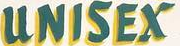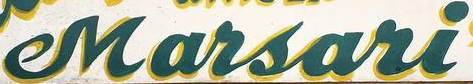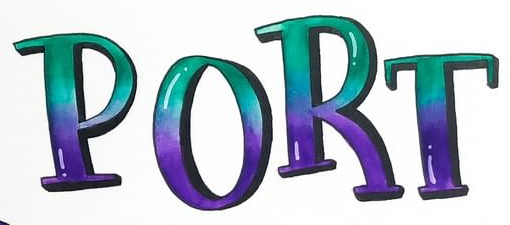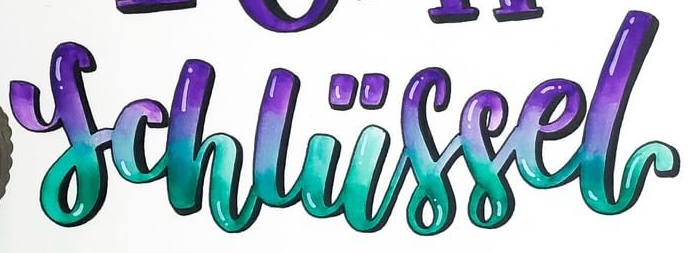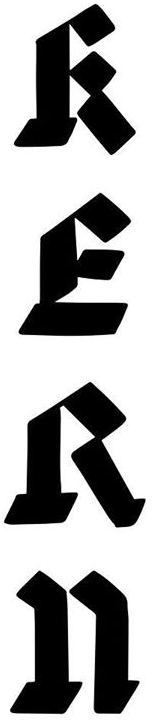Read the text content from these images in order, separated by a semicolon. UNISEX; Marsari; PORT; schliissel; RERn 